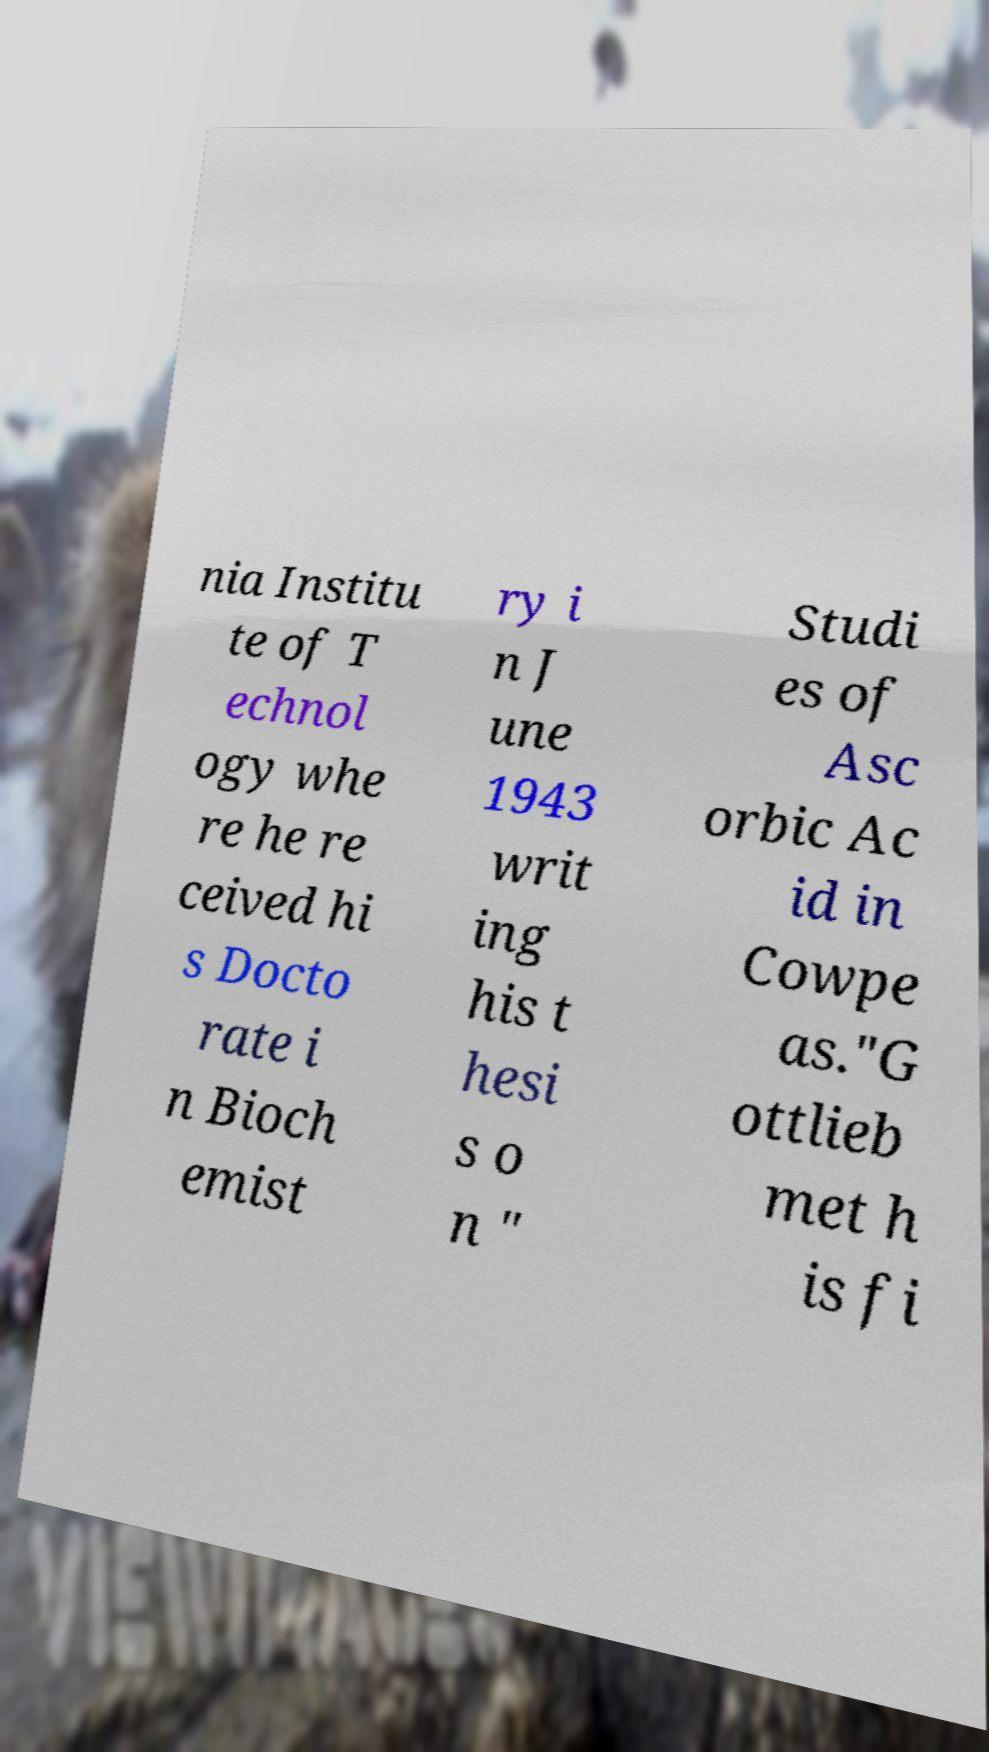Could you extract and type out the text from this image? nia Institu te of T echnol ogy whe re he re ceived hi s Docto rate i n Bioch emist ry i n J une 1943 writ ing his t hesi s o n " Studi es of Asc orbic Ac id in Cowpe as."G ottlieb met h is fi 